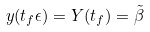Convert formula to latex. <formula><loc_0><loc_0><loc_500><loc_500>y ( t _ { f } \epsilon ) = Y ( t _ { f } ) = \tilde { \beta }</formula> 